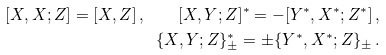Convert formula to latex. <formula><loc_0><loc_0><loc_500><loc_500>[ X , X ; Z ] = [ X , Z ] \, , \quad [ X , Y ; Z ] ^ { * } = - [ Y ^ { * } , X ^ { * } ; Z ^ { * } ] \, , \\ \{ X , Y ; Z \} _ { \pm } ^ { * } = \pm \{ Y ^ { * } , X ^ { * } ; Z \} _ { \pm } \, .</formula> 